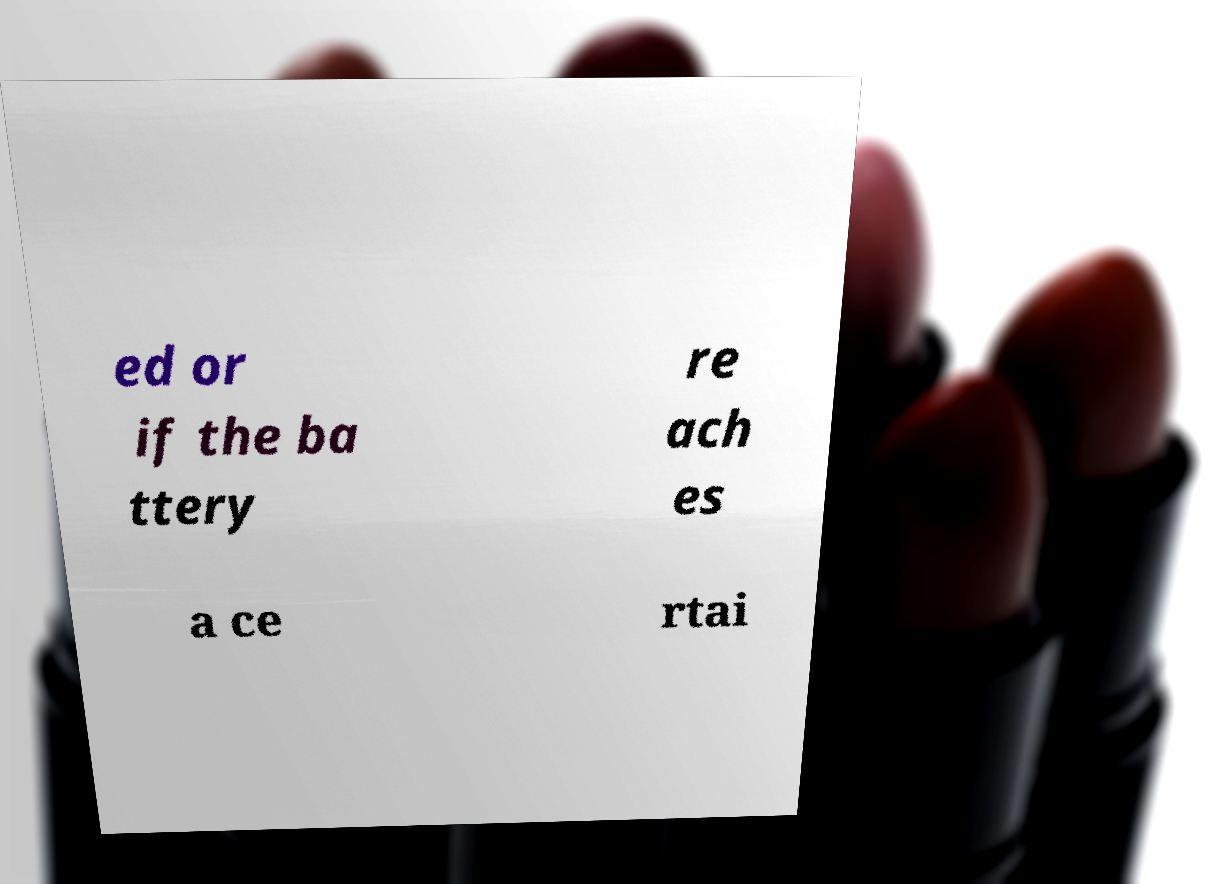Please identify and transcribe the text found in this image. ed or if the ba ttery re ach es a ce rtai 